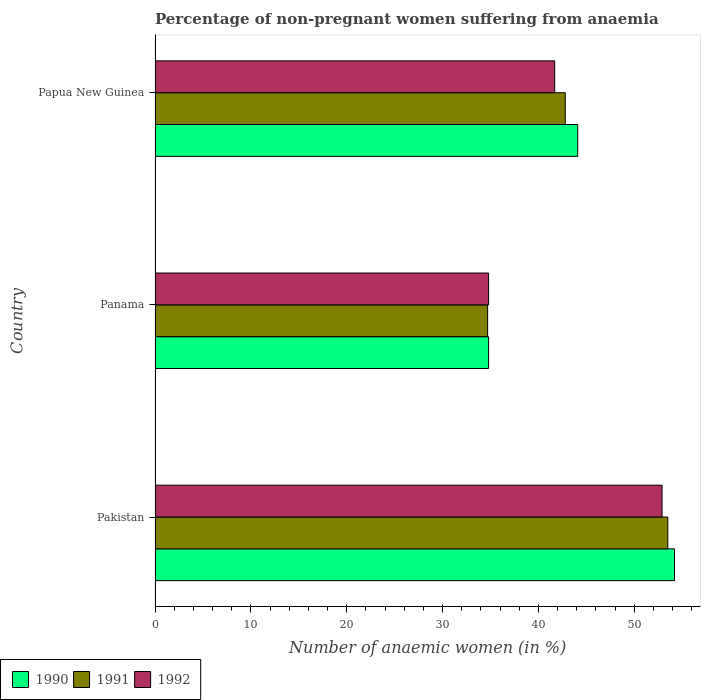How many groups of bars are there?
Provide a succinct answer. 3. Are the number of bars per tick equal to the number of legend labels?
Provide a succinct answer. Yes. How many bars are there on the 2nd tick from the top?
Provide a succinct answer. 3. How many bars are there on the 1st tick from the bottom?
Offer a very short reply. 3. What is the label of the 3rd group of bars from the top?
Make the answer very short. Pakistan. What is the percentage of non-pregnant women suffering from anaemia in 1991 in Papua New Guinea?
Give a very brief answer. 42.8. Across all countries, what is the maximum percentage of non-pregnant women suffering from anaemia in 1990?
Provide a succinct answer. 54.2. Across all countries, what is the minimum percentage of non-pregnant women suffering from anaemia in 1991?
Offer a terse response. 34.7. In which country was the percentage of non-pregnant women suffering from anaemia in 1991 minimum?
Your response must be concise. Panama. What is the total percentage of non-pregnant women suffering from anaemia in 1991 in the graph?
Provide a short and direct response. 131. What is the difference between the percentage of non-pregnant women suffering from anaemia in 1991 in Pakistan and that in Panama?
Keep it short and to the point. 18.8. What is the difference between the percentage of non-pregnant women suffering from anaemia in 1992 in Panama and the percentage of non-pregnant women suffering from anaemia in 1990 in Pakistan?
Ensure brevity in your answer.  -19.4. What is the average percentage of non-pregnant women suffering from anaemia in 1991 per country?
Offer a terse response. 43.67. What is the difference between the percentage of non-pregnant women suffering from anaemia in 1991 and percentage of non-pregnant women suffering from anaemia in 1992 in Panama?
Your answer should be very brief. -0.1. In how many countries, is the percentage of non-pregnant women suffering from anaemia in 1992 greater than 20 %?
Offer a very short reply. 3. What is the ratio of the percentage of non-pregnant women suffering from anaemia in 1991 in Panama to that in Papua New Guinea?
Give a very brief answer. 0.81. What is the difference between the highest and the second highest percentage of non-pregnant women suffering from anaemia in 1990?
Your answer should be very brief. 10.1. What is the difference between the highest and the lowest percentage of non-pregnant women suffering from anaemia in 1990?
Keep it short and to the point. 19.4. In how many countries, is the percentage of non-pregnant women suffering from anaemia in 1992 greater than the average percentage of non-pregnant women suffering from anaemia in 1992 taken over all countries?
Your answer should be very brief. 1. Is the sum of the percentage of non-pregnant women suffering from anaemia in 1992 in Pakistan and Panama greater than the maximum percentage of non-pregnant women suffering from anaemia in 1990 across all countries?
Provide a short and direct response. Yes. Is it the case that in every country, the sum of the percentage of non-pregnant women suffering from anaemia in 1992 and percentage of non-pregnant women suffering from anaemia in 1990 is greater than the percentage of non-pregnant women suffering from anaemia in 1991?
Your answer should be very brief. Yes. How many bars are there?
Your response must be concise. 9. How many countries are there in the graph?
Your response must be concise. 3. What is the difference between two consecutive major ticks on the X-axis?
Keep it short and to the point. 10. Are the values on the major ticks of X-axis written in scientific E-notation?
Your answer should be compact. No. Where does the legend appear in the graph?
Give a very brief answer. Bottom left. How are the legend labels stacked?
Your answer should be compact. Horizontal. What is the title of the graph?
Your response must be concise. Percentage of non-pregnant women suffering from anaemia. What is the label or title of the X-axis?
Offer a very short reply. Number of anaemic women (in %). What is the label or title of the Y-axis?
Provide a short and direct response. Country. What is the Number of anaemic women (in %) in 1990 in Pakistan?
Provide a succinct answer. 54.2. What is the Number of anaemic women (in %) of 1991 in Pakistan?
Make the answer very short. 53.5. What is the Number of anaemic women (in %) in 1992 in Pakistan?
Provide a short and direct response. 52.9. What is the Number of anaemic women (in %) in 1990 in Panama?
Your response must be concise. 34.8. What is the Number of anaemic women (in %) of 1991 in Panama?
Make the answer very short. 34.7. What is the Number of anaemic women (in %) in 1992 in Panama?
Your answer should be very brief. 34.8. What is the Number of anaemic women (in %) of 1990 in Papua New Guinea?
Your answer should be very brief. 44.1. What is the Number of anaemic women (in %) in 1991 in Papua New Guinea?
Keep it short and to the point. 42.8. What is the Number of anaemic women (in %) of 1992 in Papua New Guinea?
Your answer should be very brief. 41.7. Across all countries, what is the maximum Number of anaemic women (in %) in 1990?
Offer a very short reply. 54.2. Across all countries, what is the maximum Number of anaemic women (in %) of 1991?
Ensure brevity in your answer.  53.5. Across all countries, what is the maximum Number of anaemic women (in %) in 1992?
Your answer should be compact. 52.9. Across all countries, what is the minimum Number of anaemic women (in %) of 1990?
Your answer should be compact. 34.8. Across all countries, what is the minimum Number of anaemic women (in %) of 1991?
Your response must be concise. 34.7. Across all countries, what is the minimum Number of anaemic women (in %) of 1992?
Your response must be concise. 34.8. What is the total Number of anaemic women (in %) in 1990 in the graph?
Ensure brevity in your answer.  133.1. What is the total Number of anaemic women (in %) in 1991 in the graph?
Provide a succinct answer. 131. What is the total Number of anaemic women (in %) of 1992 in the graph?
Offer a terse response. 129.4. What is the difference between the Number of anaemic women (in %) of 1991 in Pakistan and that in Panama?
Make the answer very short. 18.8. What is the difference between the Number of anaemic women (in %) of 1992 in Pakistan and that in Panama?
Provide a short and direct response. 18.1. What is the difference between the Number of anaemic women (in %) in 1992 in Pakistan and that in Papua New Guinea?
Your answer should be very brief. 11.2. What is the difference between the Number of anaemic women (in %) of 1991 in Panama and that in Papua New Guinea?
Provide a short and direct response. -8.1. What is the difference between the Number of anaemic women (in %) of 1990 in Pakistan and the Number of anaemic women (in %) of 1991 in Panama?
Offer a very short reply. 19.5. What is the difference between the Number of anaemic women (in %) of 1991 in Pakistan and the Number of anaemic women (in %) of 1992 in Panama?
Offer a terse response. 18.7. What is the difference between the Number of anaemic women (in %) in 1990 in Pakistan and the Number of anaemic women (in %) in 1992 in Papua New Guinea?
Provide a succinct answer. 12.5. What is the difference between the Number of anaemic women (in %) of 1991 in Pakistan and the Number of anaemic women (in %) of 1992 in Papua New Guinea?
Make the answer very short. 11.8. What is the difference between the Number of anaemic women (in %) in 1990 in Panama and the Number of anaemic women (in %) in 1991 in Papua New Guinea?
Your response must be concise. -8. What is the average Number of anaemic women (in %) in 1990 per country?
Ensure brevity in your answer.  44.37. What is the average Number of anaemic women (in %) in 1991 per country?
Give a very brief answer. 43.67. What is the average Number of anaemic women (in %) in 1992 per country?
Provide a succinct answer. 43.13. What is the difference between the Number of anaemic women (in %) of 1990 and Number of anaemic women (in %) of 1992 in Pakistan?
Provide a short and direct response. 1.3. What is the difference between the Number of anaemic women (in %) in 1991 and Number of anaemic women (in %) in 1992 in Pakistan?
Offer a very short reply. 0.6. What is the difference between the Number of anaemic women (in %) in 1990 and Number of anaemic women (in %) in 1991 in Panama?
Ensure brevity in your answer.  0.1. What is the difference between the Number of anaemic women (in %) of 1990 and Number of anaemic women (in %) of 1991 in Papua New Guinea?
Offer a terse response. 1.3. What is the difference between the Number of anaemic women (in %) of 1990 and Number of anaemic women (in %) of 1992 in Papua New Guinea?
Ensure brevity in your answer.  2.4. What is the ratio of the Number of anaemic women (in %) in 1990 in Pakistan to that in Panama?
Ensure brevity in your answer.  1.56. What is the ratio of the Number of anaemic women (in %) in 1991 in Pakistan to that in Panama?
Offer a very short reply. 1.54. What is the ratio of the Number of anaemic women (in %) of 1992 in Pakistan to that in Panama?
Ensure brevity in your answer.  1.52. What is the ratio of the Number of anaemic women (in %) of 1990 in Pakistan to that in Papua New Guinea?
Ensure brevity in your answer.  1.23. What is the ratio of the Number of anaemic women (in %) in 1991 in Pakistan to that in Papua New Guinea?
Offer a very short reply. 1.25. What is the ratio of the Number of anaemic women (in %) in 1992 in Pakistan to that in Papua New Guinea?
Your answer should be compact. 1.27. What is the ratio of the Number of anaemic women (in %) in 1990 in Panama to that in Papua New Guinea?
Provide a short and direct response. 0.79. What is the ratio of the Number of anaemic women (in %) of 1991 in Panama to that in Papua New Guinea?
Your answer should be compact. 0.81. What is the ratio of the Number of anaemic women (in %) of 1992 in Panama to that in Papua New Guinea?
Offer a terse response. 0.83. What is the difference between the highest and the second highest Number of anaemic women (in %) of 1990?
Your response must be concise. 10.1. What is the difference between the highest and the second highest Number of anaemic women (in %) of 1991?
Make the answer very short. 10.7. What is the difference between the highest and the lowest Number of anaemic women (in %) of 1990?
Offer a terse response. 19.4. What is the difference between the highest and the lowest Number of anaemic women (in %) in 1991?
Provide a short and direct response. 18.8. 